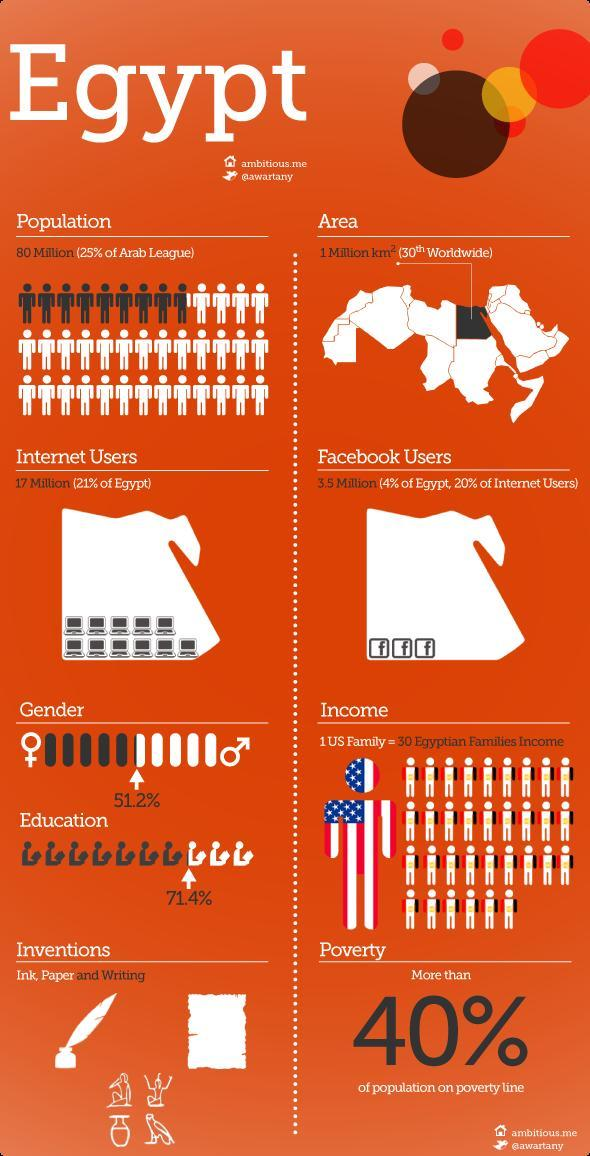What percent of the Egyptian population use Facebook?
Answer the question with a short phrase. 4% How many people in Egypt use Facebook? 3.5 million What percent of the Egyptian population are educated? 71.4% What is used by 20% of Egypt's internet users? Facebook What percent of the Egyptian population are males? 51.2% How many Internet users are there in Egypt? 17 million 